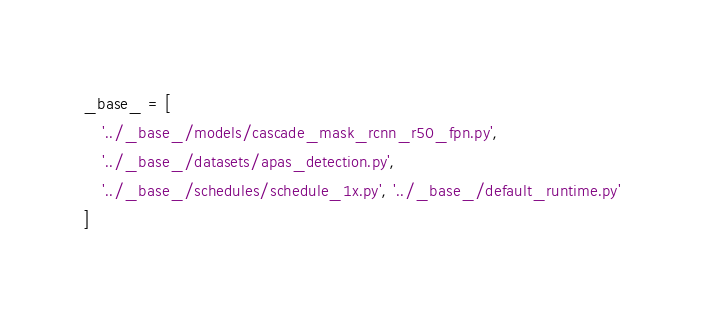<code> <loc_0><loc_0><loc_500><loc_500><_Python_>_base_ = [
    '../_base_/models/cascade_mask_rcnn_r50_fpn.py',
    '../_base_/datasets/apas_detection.py',
    '../_base_/schedules/schedule_1x.py', '../_base_/default_runtime.py'
]
</code> 